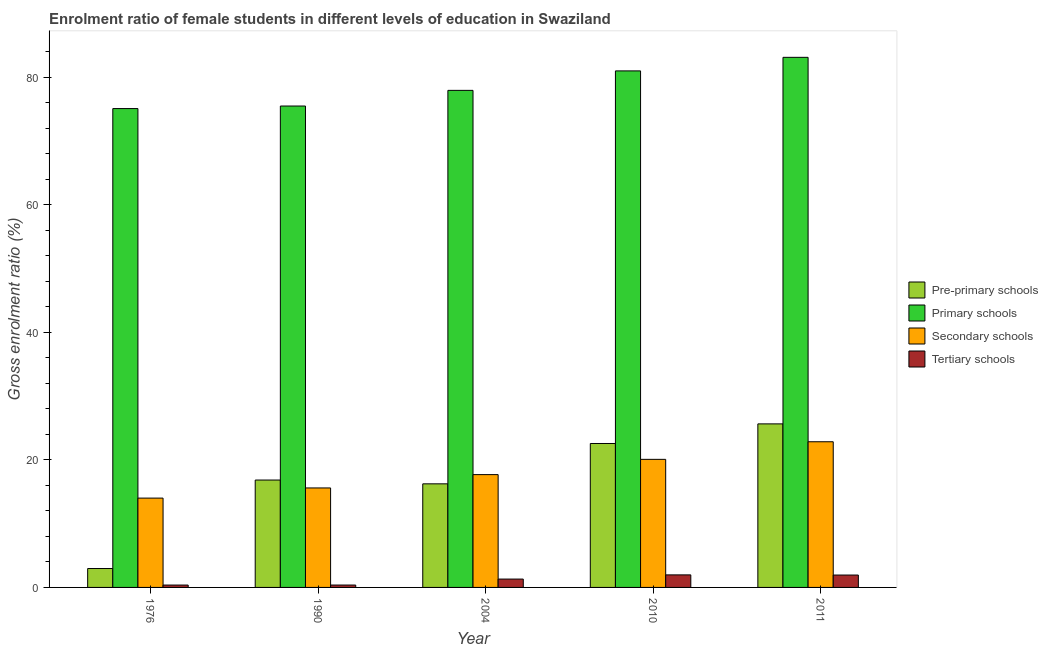How many groups of bars are there?
Offer a very short reply. 5. Are the number of bars per tick equal to the number of legend labels?
Give a very brief answer. Yes. Are the number of bars on each tick of the X-axis equal?
Keep it short and to the point. Yes. How many bars are there on the 1st tick from the right?
Provide a succinct answer. 4. In how many cases, is the number of bars for a given year not equal to the number of legend labels?
Keep it short and to the point. 0. What is the gross enrolment ratio(male) in secondary schools in 2011?
Ensure brevity in your answer.  22.85. Across all years, what is the maximum gross enrolment ratio(male) in pre-primary schools?
Offer a very short reply. 25.65. Across all years, what is the minimum gross enrolment ratio(male) in primary schools?
Provide a short and direct response. 75.11. In which year was the gross enrolment ratio(male) in primary schools maximum?
Your answer should be very brief. 2011. In which year was the gross enrolment ratio(male) in primary schools minimum?
Your answer should be compact. 1976. What is the total gross enrolment ratio(male) in tertiary schools in the graph?
Your response must be concise. 5.97. What is the difference between the gross enrolment ratio(male) in primary schools in 2010 and that in 2011?
Provide a short and direct response. -2.13. What is the difference between the gross enrolment ratio(male) in tertiary schools in 1976 and the gross enrolment ratio(male) in secondary schools in 1990?
Your answer should be very brief. -0. What is the average gross enrolment ratio(male) in tertiary schools per year?
Ensure brevity in your answer.  1.19. What is the ratio of the gross enrolment ratio(male) in secondary schools in 1990 to that in 2010?
Offer a very short reply. 0.78. Is the difference between the gross enrolment ratio(male) in secondary schools in 1990 and 2010 greater than the difference between the gross enrolment ratio(male) in tertiary schools in 1990 and 2010?
Your answer should be compact. No. What is the difference between the highest and the second highest gross enrolment ratio(male) in primary schools?
Offer a very short reply. 2.13. What is the difference between the highest and the lowest gross enrolment ratio(male) in primary schools?
Make the answer very short. 8.04. In how many years, is the gross enrolment ratio(male) in tertiary schools greater than the average gross enrolment ratio(male) in tertiary schools taken over all years?
Provide a short and direct response. 3. Is the sum of the gross enrolment ratio(male) in secondary schools in 1976 and 1990 greater than the maximum gross enrolment ratio(male) in pre-primary schools across all years?
Your answer should be very brief. Yes. Is it the case that in every year, the sum of the gross enrolment ratio(male) in secondary schools and gross enrolment ratio(male) in primary schools is greater than the sum of gross enrolment ratio(male) in pre-primary schools and gross enrolment ratio(male) in tertiary schools?
Your answer should be compact. No. What does the 1st bar from the left in 1990 represents?
Provide a succinct answer. Pre-primary schools. What does the 4th bar from the right in 1990 represents?
Give a very brief answer. Pre-primary schools. How many years are there in the graph?
Make the answer very short. 5. What is the difference between two consecutive major ticks on the Y-axis?
Your response must be concise. 20. Does the graph contain grids?
Give a very brief answer. No. How many legend labels are there?
Ensure brevity in your answer.  4. What is the title of the graph?
Your response must be concise. Enrolment ratio of female students in different levels of education in Swaziland. Does "Germany" appear as one of the legend labels in the graph?
Your response must be concise. No. What is the Gross enrolment ratio (%) of Pre-primary schools in 1976?
Your response must be concise. 2.97. What is the Gross enrolment ratio (%) in Primary schools in 1976?
Provide a succinct answer. 75.11. What is the Gross enrolment ratio (%) in Secondary schools in 1976?
Provide a short and direct response. 14.01. What is the Gross enrolment ratio (%) of Tertiary schools in 1976?
Provide a short and direct response. 0.37. What is the Gross enrolment ratio (%) in Pre-primary schools in 1990?
Ensure brevity in your answer.  16.84. What is the Gross enrolment ratio (%) of Primary schools in 1990?
Your answer should be compact. 75.51. What is the Gross enrolment ratio (%) in Secondary schools in 1990?
Keep it short and to the point. 15.61. What is the Gross enrolment ratio (%) of Tertiary schools in 1990?
Offer a terse response. 0.37. What is the Gross enrolment ratio (%) in Pre-primary schools in 2004?
Provide a short and direct response. 16.25. What is the Gross enrolment ratio (%) of Primary schools in 2004?
Keep it short and to the point. 77.97. What is the Gross enrolment ratio (%) of Secondary schools in 2004?
Provide a short and direct response. 17.7. What is the Gross enrolment ratio (%) of Tertiary schools in 2004?
Give a very brief answer. 1.31. What is the Gross enrolment ratio (%) of Pre-primary schools in 2010?
Make the answer very short. 22.58. What is the Gross enrolment ratio (%) in Primary schools in 2010?
Your answer should be very brief. 81.03. What is the Gross enrolment ratio (%) in Secondary schools in 2010?
Your response must be concise. 20.09. What is the Gross enrolment ratio (%) in Tertiary schools in 2010?
Offer a very short reply. 1.97. What is the Gross enrolment ratio (%) of Pre-primary schools in 2011?
Offer a very short reply. 25.65. What is the Gross enrolment ratio (%) of Primary schools in 2011?
Keep it short and to the point. 83.15. What is the Gross enrolment ratio (%) in Secondary schools in 2011?
Give a very brief answer. 22.85. What is the Gross enrolment ratio (%) of Tertiary schools in 2011?
Ensure brevity in your answer.  1.94. Across all years, what is the maximum Gross enrolment ratio (%) of Pre-primary schools?
Provide a succinct answer. 25.65. Across all years, what is the maximum Gross enrolment ratio (%) in Primary schools?
Make the answer very short. 83.15. Across all years, what is the maximum Gross enrolment ratio (%) of Secondary schools?
Your response must be concise. 22.85. Across all years, what is the maximum Gross enrolment ratio (%) of Tertiary schools?
Provide a short and direct response. 1.97. Across all years, what is the minimum Gross enrolment ratio (%) in Pre-primary schools?
Ensure brevity in your answer.  2.97. Across all years, what is the minimum Gross enrolment ratio (%) of Primary schools?
Provide a succinct answer. 75.11. Across all years, what is the minimum Gross enrolment ratio (%) in Secondary schools?
Provide a succinct answer. 14.01. Across all years, what is the minimum Gross enrolment ratio (%) of Tertiary schools?
Offer a very short reply. 0.37. What is the total Gross enrolment ratio (%) of Pre-primary schools in the graph?
Provide a succinct answer. 84.29. What is the total Gross enrolment ratio (%) in Primary schools in the graph?
Offer a terse response. 392.78. What is the total Gross enrolment ratio (%) in Secondary schools in the graph?
Keep it short and to the point. 90.25. What is the total Gross enrolment ratio (%) in Tertiary schools in the graph?
Ensure brevity in your answer.  5.97. What is the difference between the Gross enrolment ratio (%) in Pre-primary schools in 1976 and that in 1990?
Your response must be concise. -13.88. What is the difference between the Gross enrolment ratio (%) in Primary schools in 1976 and that in 1990?
Give a very brief answer. -0.4. What is the difference between the Gross enrolment ratio (%) in Secondary schools in 1976 and that in 1990?
Provide a succinct answer. -1.59. What is the difference between the Gross enrolment ratio (%) of Tertiary schools in 1976 and that in 1990?
Offer a terse response. -0. What is the difference between the Gross enrolment ratio (%) of Pre-primary schools in 1976 and that in 2004?
Ensure brevity in your answer.  -13.28. What is the difference between the Gross enrolment ratio (%) in Primary schools in 1976 and that in 2004?
Your response must be concise. -2.86. What is the difference between the Gross enrolment ratio (%) in Secondary schools in 1976 and that in 2004?
Your answer should be compact. -3.68. What is the difference between the Gross enrolment ratio (%) of Tertiary schools in 1976 and that in 2004?
Provide a succinct answer. -0.94. What is the difference between the Gross enrolment ratio (%) in Pre-primary schools in 1976 and that in 2010?
Provide a short and direct response. -19.61. What is the difference between the Gross enrolment ratio (%) of Primary schools in 1976 and that in 2010?
Make the answer very short. -5.91. What is the difference between the Gross enrolment ratio (%) in Secondary schools in 1976 and that in 2010?
Offer a terse response. -6.08. What is the difference between the Gross enrolment ratio (%) in Tertiary schools in 1976 and that in 2010?
Keep it short and to the point. -1.6. What is the difference between the Gross enrolment ratio (%) in Pre-primary schools in 1976 and that in 2011?
Ensure brevity in your answer.  -22.69. What is the difference between the Gross enrolment ratio (%) of Primary schools in 1976 and that in 2011?
Ensure brevity in your answer.  -8.04. What is the difference between the Gross enrolment ratio (%) in Secondary schools in 1976 and that in 2011?
Your response must be concise. -8.84. What is the difference between the Gross enrolment ratio (%) in Tertiary schools in 1976 and that in 2011?
Offer a very short reply. -1.57. What is the difference between the Gross enrolment ratio (%) of Pre-primary schools in 1990 and that in 2004?
Keep it short and to the point. 0.59. What is the difference between the Gross enrolment ratio (%) in Primary schools in 1990 and that in 2004?
Provide a succinct answer. -2.46. What is the difference between the Gross enrolment ratio (%) in Secondary schools in 1990 and that in 2004?
Offer a very short reply. -2.09. What is the difference between the Gross enrolment ratio (%) in Tertiary schools in 1990 and that in 2004?
Keep it short and to the point. -0.94. What is the difference between the Gross enrolment ratio (%) of Pre-primary schools in 1990 and that in 2010?
Ensure brevity in your answer.  -5.73. What is the difference between the Gross enrolment ratio (%) in Primary schools in 1990 and that in 2010?
Ensure brevity in your answer.  -5.51. What is the difference between the Gross enrolment ratio (%) of Secondary schools in 1990 and that in 2010?
Give a very brief answer. -4.49. What is the difference between the Gross enrolment ratio (%) of Tertiary schools in 1990 and that in 2010?
Make the answer very short. -1.59. What is the difference between the Gross enrolment ratio (%) in Pre-primary schools in 1990 and that in 2011?
Your answer should be very brief. -8.81. What is the difference between the Gross enrolment ratio (%) of Primary schools in 1990 and that in 2011?
Give a very brief answer. -7.64. What is the difference between the Gross enrolment ratio (%) in Secondary schools in 1990 and that in 2011?
Offer a terse response. -7.25. What is the difference between the Gross enrolment ratio (%) of Tertiary schools in 1990 and that in 2011?
Your answer should be very brief. -1.57. What is the difference between the Gross enrolment ratio (%) in Pre-primary schools in 2004 and that in 2010?
Ensure brevity in your answer.  -6.33. What is the difference between the Gross enrolment ratio (%) in Primary schools in 2004 and that in 2010?
Your answer should be compact. -3.05. What is the difference between the Gross enrolment ratio (%) in Secondary schools in 2004 and that in 2010?
Ensure brevity in your answer.  -2.39. What is the difference between the Gross enrolment ratio (%) in Tertiary schools in 2004 and that in 2010?
Provide a short and direct response. -0.66. What is the difference between the Gross enrolment ratio (%) in Pre-primary schools in 2004 and that in 2011?
Provide a short and direct response. -9.4. What is the difference between the Gross enrolment ratio (%) in Primary schools in 2004 and that in 2011?
Your answer should be compact. -5.18. What is the difference between the Gross enrolment ratio (%) of Secondary schools in 2004 and that in 2011?
Provide a short and direct response. -5.15. What is the difference between the Gross enrolment ratio (%) in Tertiary schools in 2004 and that in 2011?
Your answer should be very brief. -0.63. What is the difference between the Gross enrolment ratio (%) of Pre-primary schools in 2010 and that in 2011?
Give a very brief answer. -3.08. What is the difference between the Gross enrolment ratio (%) of Primary schools in 2010 and that in 2011?
Keep it short and to the point. -2.13. What is the difference between the Gross enrolment ratio (%) of Secondary schools in 2010 and that in 2011?
Your response must be concise. -2.76. What is the difference between the Gross enrolment ratio (%) of Tertiary schools in 2010 and that in 2011?
Your answer should be very brief. 0.02. What is the difference between the Gross enrolment ratio (%) of Pre-primary schools in 1976 and the Gross enrolment ratio (%) of Primary schools in 1990?
Provide a succinct answer. -72.55. What is the difference between the Gross enrolment ratio (%) in Pre-primary schools in 1976 and the Gross enrolment ratio (%) in Secondary schools in 1990?
Give a very brief answer. -12.64. What is the difference between the Gross enrolment ratio (%) in Pre-primary schools in 1976 and the Gross enrolment ratio (%) in Tertiary schools in 1990?
Offer a terse response. 2.59. What is the difference between the Gross enrolment ratio (%) of Primary schools in 1976 and the Gross enrolment ratio (%) of Secondary schools in 1990?
Your answer should be very brief. 59.51. What is the difference between the Gross enrolment ratio (%) in Primary schools in 1976 and the Gross enrolment ratio (%) in Tertiary schools in 1990?
Provide a short and direct response. 74.74. What is the difference between the Gross enrolment ratio (%) of Secondary schools in 1976 and the Gross enrolment ratio (%) of Tertiary schools in 1990?
Keep it short and to the point. 13.64. What is the difference between the Gross enrolment ratio (%) of Pre-primary schools in 1976 and the Gross enrolment ratio (%) of Primary schools in 2004?
Make the answer very short. -75.01. What is the difference between the Gross enrolment ratio (%) in Pre-primary schools in 1976 and the Gross enrolment ratio (%) in Secondary schools in 2004?
Offer a very short reply. -14.73. What is the difference between the Gross enrolment ratio (%) of Pre-primary schools in 1976 and the Gross enrolment ratio (%) of Tertiary schools in 2004?
Keep it short and to the point. 1.66. What is the difference between the Gross enrolment ratio (%) in Primary schools in 1976 and the Gross enrolment ratio (%) in Secondary schools in 2004?
Your answer should be very brief. 57.42. What is the difference between the Gross enrolment ratio (%) of Primary schools in 1976 and the Gross enrolment ratio (%) of Tertiary schools in 2004?
Your response must be concise. 73.8. What is the difference between the Gross enrolment ratio (%) of Secondary schools in 1976 and the Gross enrolment ratio (%) of Tertiary schools in 2004?
Provide a succinct answer. 12.7. What is the difference between the Gross enrolment ratio (%) in Pre-primary schools in 1976 and the Gross enrolment ratio (%) in Primary schools in 2010?
Ensure brevity in your answer.  -78.06. What is the difference between the Gross enrolment ratio (%) of Pre-primary schools in 1976 and the Gross enrolment ratio (%) of Secondary schools in 2010?
Offer a terse response. -17.12. What is the difference between the Gross enrolment ratio (%) of Pre-primary schools in 1976 and the Gross enrolment ratio (%) of Tertiary schools in 2010?
Provide a succinct answer. 1. What is the difference between the Gross enrolment ratio (%) of Primary schools in 1976 and the Gross enrolment ratio (%) of Secondary schools in 2010?
Provide a succinct answer. 55.02. What is the difference between the Gross enrolment ratio (%) in Primary schools in 1976 and the Gross enrolment ratio (%) in Tertiary schools in 2010?
Your answer should be compact. 73.15. What is the difference between the Gross enrolment ratio (%) of Secondary schools in 1976 and the Gross enrolment ratio (%) of Tertiary schools in 2010?
Keep it short and to the point. 12.04. What is the difference between the Gross enrolment ratio (%) in Pre-primary schools in 1976 and the Gross enrolment ratio (%) in Primary schools in 2011?
Your answer should be very brief. -80.19. What is the difference between the Gross enrolment ratio (%) of Pre-primary schools in 1976 and the Gross enrolment ratio (%) of Secondary schools in 2011?
Make the answer very short. -19.88. What is the difference between the Gross enrolment ratio (%) in Pre-primary schools in 1976 and the Gross enrolment ratio (%) in Tertiary schools in 2011?
Your answer should be very brief. 1.02. What is the difference between the Gross enrolment ratio (%) in Primary schools in 1976 and the Gross enrolment ratio (%) in Secondary schools in 2011?
Provide a short and direct response. 52.26. What is the difference between the Gross enrolment ratio (%) of Primary schools in 1976 and the Gross enrolment ratio (%) of Tertiary schools in 2011?
Offer a terse response. 73.17. What is the difference between the Gross enrolment ratio (%) in Secondary schools in 1976 and the Gross enrolment ratio (%) in Tertiary schools in 2011?
Your answer should be very brief. 12.07. What is the difference between the Gross enrolment ratio (%) of Pre-primary schools in 1990 and the Gross enrolment ratio (%) of Primary schools in 2004?
Offer a terse response. -61.13. What is the difference between the Gross enrolment ratio (%) of Pre-primary schools in 1990 and the Gross enrolment ratio (%) of Secondary schools in 2004?
Offer a terse response. -0.85. What is the difference between the Gross enrolment ratio (%) of Pre-primary schools in 1990 and the Gross enrolment ratio (%) of Tertiary schools in 2004?
Ensure brevity in your answer.  15.53. What is the difference between the Gross enrolment ratio (%) of Primary schools in 1990 and the Gross enrolment ratio (%) of Secondary schools in 2004?
Your answer should be compact. 57.82. What is the difference between the Gross enrolment ratio (%) of Primary schools in 1990 and the Gross enrolment ratio (%) of Tertiary schools in 2004?
Offer a very short reply. 74.2. What is the difference between the Gross enrolment ratio (%) in Secondary schools in 1990 and the Gross enrolment ratio (%) in Tertiary schools in 2004?
Provide a short and direct response. 14.3. What is the difference between the Gross enrolment ratio (%) of Pre-primary schools in 1990 and the Gross enrolment ratio (%) of Primary schools in 2010?
Provide a succinct answer. -64.18. What is the difference between the Gross enrolment ratio (%) of Pre-primary schools in 1990 and the Gross enrolment ratio (%) of Secondary schools in 2010?
Offer a very short reply. -3.25. What is the difference between the Gross enrolment ratio (%) in Pre-primary schools in 1990 and the Gross enrolment ratio (%) in Tertiary schools in 2010?
Make the answer very short. 14.88. What is the difference between the Gross enrolment ratio (%) of Primary schools in 1990 and the Gross enrolment ratio (%) of Secondary schools in 2010?
Keep it short and to the point. 55.42. What is the difference between the Gross enrolment ratio (%) in Primary schools in 1990 and the Gross enrolment ratio (%) in Tertiary schools in 2010?
Make the answer very short. 73.55. What is the difference between the Gross enrolment ratio (%) in Secondary schools in 1990 and the Gross enrolment ratio (%) in Tertiary schools in 2010?
Give a very brief answer. 13.64. What is the difference between the Gross enrolment ratio (%) in Pre-primary schools in 1990 and the Gross enrolment ratio (%) in Primary schools in 2011?
Keep it short and to the point. -66.31. What is the difference between the Gross enrolment ratio (%) of Pre-primary schools in 1990 and the Gross enrolment ratio (%) of Secondary schools in 2011?
Ensure brevity in your answer.  -6.01. What is the difference between the Gross enrolment ratio (%) in Pre-primary schools in 1990 and the Gross enrolment ratio (%) in Tertiary schools in 2011?
Give a very brief answer. 14.9. What is the difference between the Gross enrolment ratio (%) of Primary schools in 1990 and the Gross enrolment ratio (%) of Secondary schools in 2011?
Provide a short and direct response. 52.66. What is the difference between the Gross enrolment ratio (%) of Primary schools in 1990 and the Gross enrolment ratio (%) of Tertiary schools in 2011?
Give a very brief answer. 73.57. What is the difference between the Gross enrolment ratio (%) of Secondary schools in 1990 and the Gross enrolment ratio (%) of Tertiary schools in 2011?
Keep it short and to the point. 13.66. What is the difference between the Gross enrolment ratio (%) in Pre-primary schools in 2004 and the Gross enrolment ratio (%) in Primary schools in 2010?
Keep it short and to the point. -64.78. What is the difference between the Gross enrolment ratio (%) in Pre-primary schools in 2004 and the Gross enrolment ratio (%) in Secondary schools in 2010?
Provide a succinct answer. -3.84. What is the difference between the Gross enrolment ratio (%) in Pre-primary schools in 2004 and the Gross enrolment ratio (%) in Tertiary schools in 2010?
Provide a short and direct response. 14.28. What is the difference between the Gross enrolment ratio (%) in Primary schools in 2004 and the Gross enrolment ratio (%) in Secondary schools in 2010?
Your answer should be very brief. 57.88. What is the difference between the Gross enrolment ratio (%) of Primary schools in 2004 and the Gross enrolment ratio (%) of Tertiary schools in 2010?
Provide a succinct answer. 76. What is the difference between the Gross enrolment ratio (%) of Secondary schools in 2004 and the Gross enrolment ratio (%) of Tertiary schools in 2010?
Provide a short and direct response. 15.73. What is the difference between the Gross enrolment ratio (%) of Pre-primary schools in 2004 and the Gross enrolment ratio (%) of Primary schools in 2011?
Ensure brevity in your answer.  -66.9. What is the difference between the Gross enrolment ratio (%) of Pre-primary schools in 2004 and the Gross enrolment ratio (%) of Secondary schools in 2011?
Offer a terse response. -6.6. What is the difference between the Gross enrolment ratio (%) of Pre-primary schools in 2004 and the Gross enrolment ratio (%) of Tertiary schools in 2011?
Offer a very short reply. 14.31. What is the difference between the Gross enrolment ratio (%) in Primary schools in 2004 and the Gross enrolment ratio (%) in Secondary schools in 2011?
Keep it short and to the point. 55.12. What is the difference between the Gross enrolment ratio (%) of Primary schools in 2004 and the Gross enrolment ratio (%) of Tertiary schools in 2011?
Make the answer very short. 76.03. What is the difference between the Gross enrolment ratio (%) of Secondary schools in 2004 and the Gross enrolment ratio (%) of Tertiary schools in 2011?
Keep it short and to the point. 15.75. What is the difference between the Gross enrolment ratio (%) in Pre-primary schools in 2010 and the Gross enrolment ratio (%) in Primary schools in 2011?
Offer a very short reply. -60.57. What is the difference between the Gross enrolment ratio (%) in Pre-primary schools in 2010 and the Gross enrolment ratio (%) in Secondary schools in 2011?
Offer a terse response. -0.27. What is the difference between the Gross enrolment ratio (%) in Pre-primary schools in 2010 and the Gross enrolment ratio (%) in Tertiary schools in 2011?
Give a very brief answer. 20.64. What is the difference between the Gross enrolment ratio (%) in Primary schools in 2010 and the Gross enrolment ratio (%) in Secondary schools in 2011?
Ensure brevity in your answer.  58.17. What is the difference between the Gross enrolment ratio (%) of Primary schools in 2010 and the Gross enrolment ratio (%) of Tertiary schools in 2011?
Your response must be concise. 79.08. What is the difference between the Gross enrolment ratio (%) in Secondary schools in 2010 and the Gross enrolment ratio (%) in Tertiary schools in 2011?
Your answer should be very brief. 18.15. What is the average Gross enrolment ratio (%) of Pre-primary schools per year?
Provide a short and direct response. 16.86. What is the average Gross enrolment ratio (%) of Primary schools per year?
Offer a very short reply. 78.56. What is the average Gross enrolment ratio (%) in Secondary schools per year?
Make the answer very short. 18.05. What is the average Gross enrolment ratio (%) of Tertiary schools per year?
Offer a terse response. 1.19. In the year 1976, what is the difference between the Gross enrolment ratio (%) of Pre-primary schools and Gross enrolment ratio (%) of Primary schools?
Your response must be concise. -72.15. In the year 1976, what is the difference between the Gross enrolment ratio (%) of Pre-primary schools and Gross enrolment ratio (%) of Secondary schools?
Your answer should be very brief. -11.05. In the year 1976, what is the difference between the Gross enrolment ratio (%) of Pre-primary schools and Gross enrolment ratio (%) of Tertiary schools?
Make the answer very short. 2.59. In the year 1976, what is the difference between the Gross enrolment ratio (%) of Primary schools and Gross enrolment ratio (%) of Secondary schools?
Provide a succinct answer. 61.1. In the year 1976, what is the difference between the Gross enrolment ratio (%) in Primary schools and Gross enrolment ratio (%) in Tertiary schools?
Your answer should be very brief. 74.74. In the year 1976, what is the difference between the Gross enrolment ratio (%) of Secondary schools and Gross enrolment ratio (%) of Tertiary schools?
Make the answer very short. 13.64. In the year 1990, what is the difference between the Gross enrolment ratio (%) in Pre-primary schools and Gross enrolment ratio (%) in Primary schools?
Make the answer very short. -58.67. In the year 1990, what is the difference between the Gross enrolment ratio (%) of Pre-primary schools and Gross enrolment ratio (%) of Secondary schools?
Give a very brief answer. 1.24. In the year 1990, what is the difference between the Gross enrolment ratio (%) of Pre-primary schools and Gross enrolment ratio (%) of Tertiary schools?
Your response must be concise. 16.47. In the year 1990, what is the difference between the Gross enrolment ratio (%) of Primary schools and Gross enrolment ratio (%) of Secondary schools?
Provide a succinct answer. 59.91. In the year 1990, what is the difference between the Gross enrolment ratio (%) in Primary schools and Gross enrolment ratio (%) in Tertiary schools?
Your answer should be compact. 75.14. In the year 1990, what is the difference between the Gross enrolment ratio (%) of Secondary schools and Gross enrolment ratio (%) of Tertiary schools?
Offer a terse response. 15.23. In the year 2004, what is the difference between the Gross enrolment ratio (%) in Pre-primary schools and Gross enrolment ratio (%) in Primary schools?
Provide a short and direct response. -61.72. In the year 2004, what is the difference between the Gross enrolment ratio (%) of Pre-primary schools and Gross enrolment ratio (%) of Secondary schools?
Provide a succinct answer. -1.45. In the year 2004, what is the difference between the Gross enrolment ratio (%) of Pre-primary schools and Gross enrolment ratio (%) of Tertiary schools?
Give a very brief answer. 14.94. In the year 2004, what is the difference between the Gross enrolment ratio (%) in Primary schools and Gross enrolment ratio (%) in Secondary schools?
Make the answer very short. 60.28. In the year 2004, what is the difference between the Gross enrolment ratio (%) in Primary schools and Gross enrolment ratio (%) in Tertiary schools?
Give a very brief answer. 76.66. In the year 2004, what is the difference between the Gross enrolment ratio (%) of Secondary schools and Gross enrolment ratio (%) of Tertiary schools?
Your answer should be very brief. 16.39. In the year 2010, what is the difference between the Gross enrolment ratio (%) of Pre-primary schools and Gross enrolment ratio (%) of Primary schools?
Give a very brief answer. -58.45. In the year 2010, what is the difference between the Gross enrolment ratio (%) in Pre-primary schools and Gross enrolment ratio (%) in Secondary schools?
Your answer should be very brief. 2.49. In the year 2010, what is the difference between the Gross enrolment ratio (%) of Pre-primary schools and Gross enrolment ratio (%) of Tertiary schools?
Give a very brief answer. 20.61. In the year 2010, what is the difference between the Gross enrolment ratio (%) in Primary schools and Gross enrolment ratio (%) in Secondary schools?
Offer a very short reply. 60.93. In the year 2010, what is the difference between the Gross enrolment ratio (%) in Primary schools and Gross enrolment ratio (%) in Tertiary schools?
Offer a very short reply. 79.06. In the year 2010, what is the difference between the Gross enrolment ratio (%) of Secondary schools and Gross enrolment ratio (%) of Tertiary schools?
Offer a very short reply. 18.12. In the year 2011, what is the difference between the Gross enrolment ratio (%) of Pre-primary schools and Gross enrolment ratio (%) of Primary schools?
Offer a very short reply. -57.5. In the year 2011, what is the difference between the Gross enrolment ratio (%) in Pre-primary schools and Gross enrolment ratio (%) in Secondary schools?
Keep it short and to the point. 2.8. In the year 2011, what is the difference between the Gross enrolment ratio (%) of Pre-primary schools and Gross enrolment ratio (%) of Tertiary schools?
Your response must be concise. 23.71. In the year 2011, what is the difference between the Gross enrolment ratio (%) of Primary schools and Gross enrolment ratio (%) of Secondary schools?
Your answer should be very brief. 60.3. In the year 2011, what is the difference between the Gross enrolment ratio (%) of Primary schools and Gross enrolment ratio (%) of Tertiary schools?
Give a very brief answer. 81.21. In the year 2011, what is the difference between the Gross enrolment ratio (%) in Secondary schools and Gross enrolment ratio (%) in Tertiary schools?
Your answer should be compact. 20.91. What is the ratio of the Gross enrolment ratio (%) of Pre-primary schools in 1976 to that in 1990?
Make the answer very short. 0.18. What is the ratio of the Gross enrolment ratio (%) in Secondary schools in 1976 to that in 1990?
Provide a succinct answer. 0.9. What is the ratio of the Gross enrolment ratio (%) in Tertiary schools in 1976 to that in 1990?
Your response must be concise. 1. What is the ratio of the Gross enrolment ratio (%) of Pre-primary schools in 1976 to that in 2004?
Your response must be concise. 0.18. What is the ratio of the Gross enrolment ratio (%) of Primary schools in 1976 to that in 2004?
Ensure brevity in your answer.  0.96. What is the ratio of the Gross enrolment ratio (%) in Secondary schools in 1976 to that in 2004?
Offer a very short reply. 0.79. What is the ratio of the Gross enrolment ratio (%) in Tertiary schools in 1976 to that in 2004?
Offer a terse response. 0.28. What is the ratio of the Gross enrolment ratio (%) of Pre-primary schools in 1976 to that in 2010?
Keep it short and to the point. 0.13. What is the ratio of the Gross enrolment ratio (%) in Primary schools in 1976 to that in 2010?
Make the answer very short. 0.93. What is the ratio of the Gross enrolment ratio (%) in Secondary schools in 1976 to that in 2010?
Your answer should be very brief. 0.7. What is the ratio of the Gross enrolment ratio (%) in Tertiary schools in 1976 to that in 2010?
Offer a very short reply. 0.19. What is the ratio of the Gross enrolment ratio (%) of Pre-primary schools in 1976 to that in 2011?
Ensure brevity in your answer.  0.12. What is the ratio of the Gross enrolment ratio (%) of Primary schools in 1976 to that in 2011?
Keep it short and to the point. 0.9. What is the ratio of the Gross enrolment ratio (%) of Secondary schools in 1976 to that in 2011?
Provide a short and direct response. 0.61. What is the ratio of the Gross enrolment ratio (%) of Tertiary schools in 1976 to that in 2011?
Keep it short and to the point. 0.19. What is the ratio of the Gross enrolment ratio (%) of Pre-primary schools in 1990 to that in 2004?
Offer a terse response. 1.04. What is the ratio of the Gross enrolment ratio (%) in Primary schools in 1990 to that in 2004?
Ensure brevity in your answer.  0.97. What is the ratio of the Gross enrolment ratio (%) in Secondary schools in 1990 to that in 2004?
Provide a succinct answer. 0.88. What is the ratio of the Gross enrolment ratio (%) in Tertiary schools in 1990 to that in 2004?
Provide a short and direct response. 0.29. What is the ratio of the Gross enrolment ratio (%) of Pre-primary schools in 1990 to that in 2010?
Your answer should be compact. 0.75. What is the ratio of the Gross enrolment ratio (%) in Primary schools in 1990 to that in 2010?
Provide a succinct answer. 0.93. What is the ratio of the Gross enrolment ratio (%) in Secondary schools in 1990 to that in 2010?
Ensure brevity in your answer.  0.78. What is the ratio of the Gross enrolment ratio (%) in Tertiary schools in 1990 to that in 2010?
Offer a terse response. 0.19. What is the ratio of the Gross enrolment ratio (%) of Pre-primary schools in 1990 to that in 2011?
Keep it short and to the point. 0.66. What is the ratio of the Gross enrolment ratio (%) of Primary schools in 1990 to that in 2011?
Provide a short and direct response. 0.91. What is the ratio of the Gross enrolment ratio (%) in Secondary schools in 1990 to that in 2011?
Make the answer very short. 0.68. What is the ratio of the Gross enrolment ratio (%) in Tertiary schools in 1990 to that in 2011?
Ensure brevity in your answer.  0.19. What is the ratio of the Gross enrolment ratio (%) of Pre-primary schools in 2004 to that in 2010?
Your response must be concise. 0.72. What is the ratio of the Gross enrolment ratio (%) of Primary schools in 2004 to that in 2010?
Ensure brevity in your answer.  0.96. What is the ratio of the Gross enrolment ratio (%) in Secondary schools in 2004 to that in 2010?
Your answer should be compact. 0.88. What is the ratio of the Gross enrolment ratio (%) in Tertiary schools in 2004 to that in 2010?
Give a very brief answer. 0.67. What is the ratio of the Gross enrolment ratio (%) of Pre-primary schools in 2004 to that in 2011?
Ensure brevity in your answer.  0.63. What is the ratio of the Gross enrolment ratio (%) of Primary schools in 2004 to that in 2011?
Keep it short and to the point. 0.94. What is the ratio of the Gross enrolment ratio (%) of Secondary schools in 2004 to that in 2011?
Your answer should be compact. 0.77. What is the ratio of the Gross enrolment ratio (%) of Tertiary schools in 2004 to that in 2011?
Offer a very short reply. 0.67. What is the ratio of the Gross enrolment ratio (%) in Pre-primary schools in 2010 to that in 2011?
Give a very brief answer. 0.88. What is the ratio of the Gross enrolment ratio (%) in Primary schools in 2010 to that in 2011?
Keep it short and to the point. 0.97. What is the ratio of the Gross enrolment ratio (%) of Secondary schools in 2010 to that in 2011?
Offer a very short reply. 0.88. What is the ratio of the Gross enrolment ratio (%) in Tertiary schools in 2010 to that in 2011?
Your response must be concise. 1.01. What is the difference between the highest and the second highest Gross enrolment ratio (%) of Pre-primary schools?
Your response must be concise. 3.08. What is the difference between the highest and the second highest Gross enrolment ratio (%) in Primary schools?
Ensure brevity in your answer.  2.13. What is the difference between the highest and the second highest Gross enrolment ratio (%) of Secondary schools?
Offer a terse response. 2.76. What is the difference between the highest and the second highest Gross enrolment ratio (%) in Tertiary schools?
Offer a terse response. 0.02. What is the difference between the highest and the lowest Gross enrolment ratio (%) of Pre-primary schools?
Keep it short and to the point. 22.69. What is the difference between the highest and the lowest Gross enrolment ratio (%) of Primary schools?
Your response must be concise. 8.04. What is the difference between the highest and the lowest Gross enrolment ratio (%) in Secondary schools?
Keep it short and to the point. 8.84. What is the difference between the highest and the lowest Gross enrolment ratio (%) in Tertiary schools?
Provide a succinct answer. 1.6. 